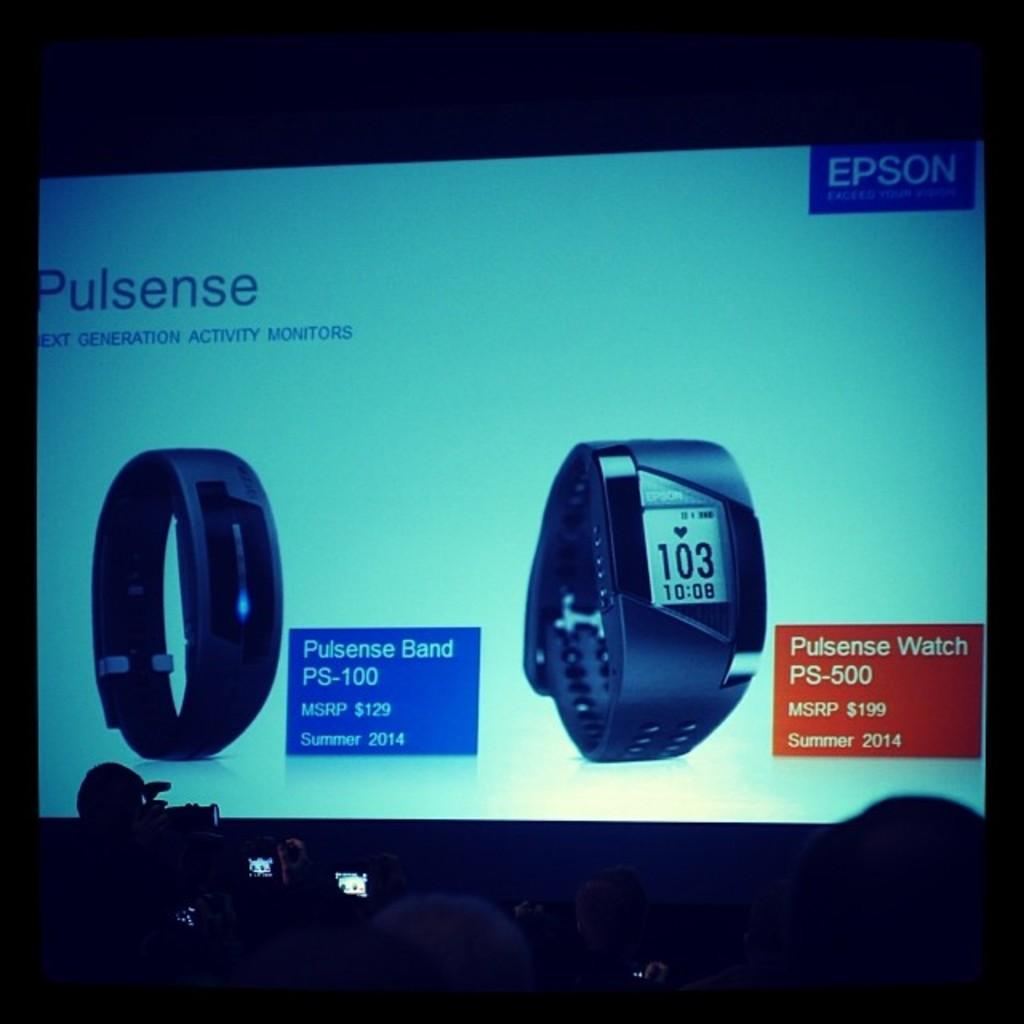Provide a one-sentence caption for the provided image. A large screen showing an advertisement for a Pulsense activity monitor. 